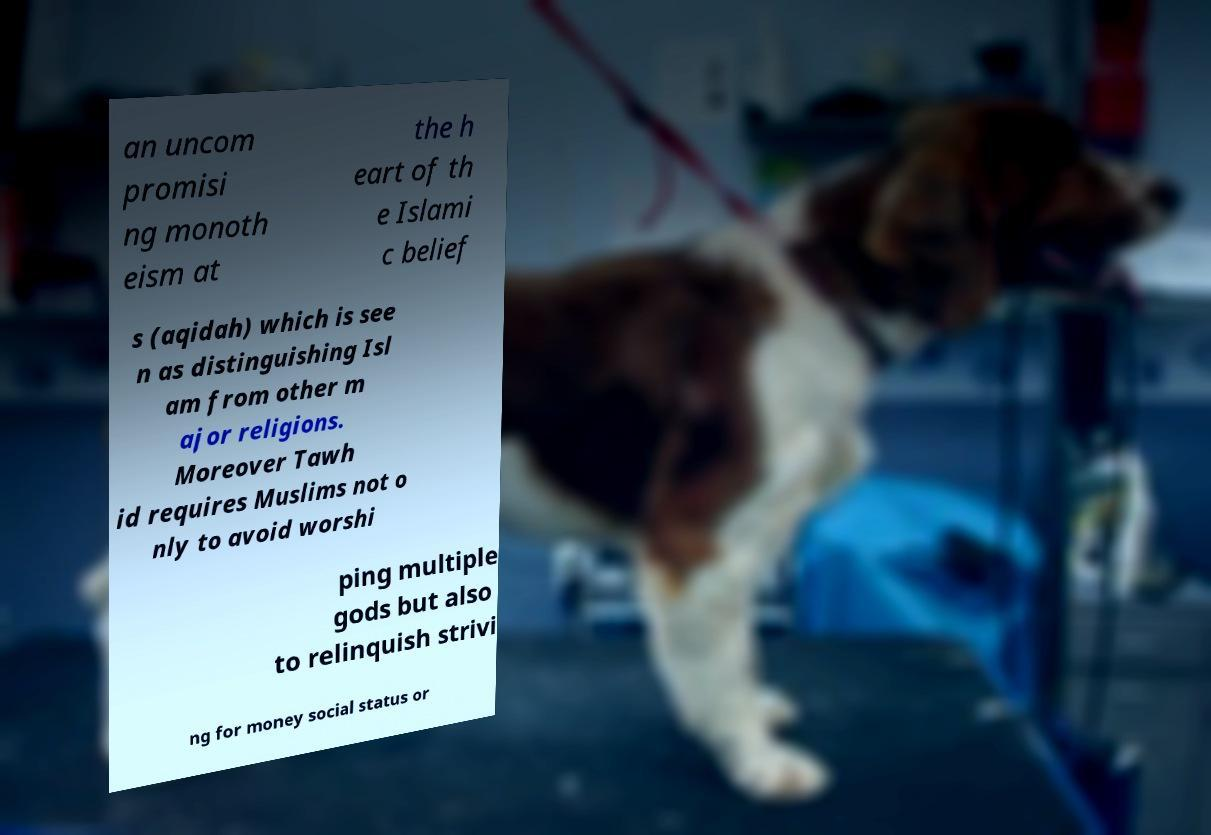What messages or text are displayed in this image? I need them in a readable, typed format. an uncom promisi ng monoth eism at the h eart of th e Islami c belief s (aqidah) which is see n as distinguishing Isl am from other m ajor religions. Moreover Tawh id requires Muslims not o nly to avoid worshi ping multiple gods but also to relinquish strivi ng for money social status or 